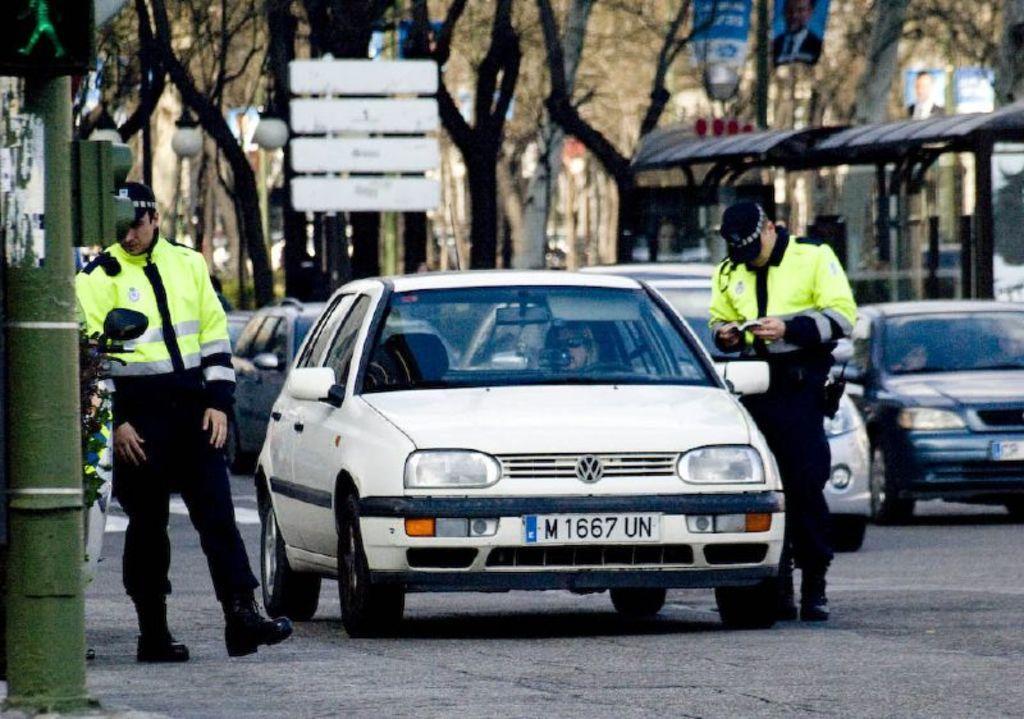In one or two sentences, can you explain what this image depicts? Here we can see two persons are standing on the road and there are cars. In the background there are trees and this is a shed. There is a banner and this is pole. 